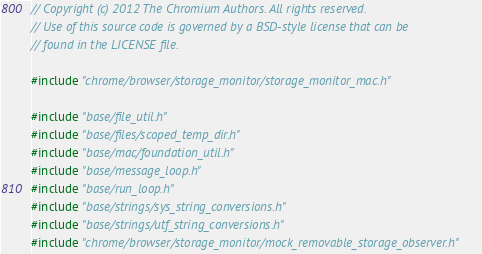<code> <loc_0><loc_0><loc_500><loc_500><_ObjectiveC_>// Copyright (c) 2012 The Chromium Authors. All rights reserved.
// Use of this source code is governed by a BSD-style license that can be
// found in the LICENSE file.

#include "chrome/browser/storage_monitor/storage_monitor_mac.h"

#include "base/file_util.h"
#include "base/files/scoped_temp_dir.h"
#include "base/mac/foundation_util.h"
#include "base/message_loop.h"
#include "base/run_loop.h"
#include "base/strings/sys_string_conversions.h"
#include "base/strings/utf_string_conversions.h"
#include "chrome/browser/storage_monitor/mock_removable_storage_observer.h"</code> 